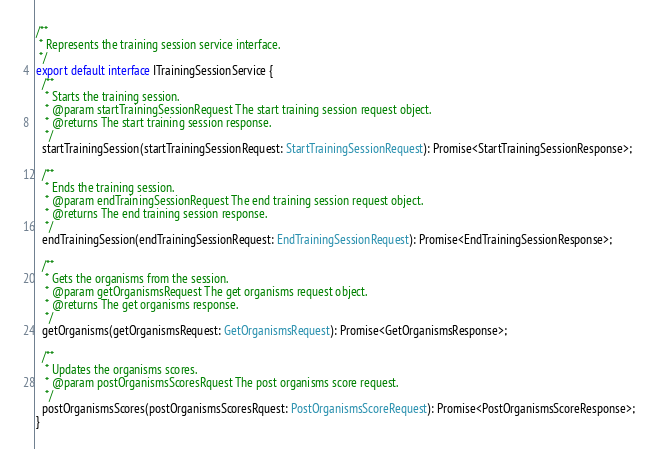<code> <loc_0><loc_0><loc_500><loc_500><_TypeScript_>/**
 * Represents the training session service interface.
 */
export default interface ITrainingSessionService {
  /**
   * Starts the training session.
   * @param startTrainingSessionRequest The start training session request object.
   * @returns The start training session response.
   */
  startTrainingSession(startTrainingSessionRequest: StartTrainingSessionRequest): Promise<StartTrainingSessionResponse>;

  /**
   * Ends the training session.
   * @param endTrainingSessionRequest The end training session request object.
   * @returns The end training session response.
   */
  endTrainingSession(endTrainingSessionRequest: EndTrainingSessionRequest): Promise<EndTrainingSessionResponse>;

  /**
   * Gets the organisms from the session.
   * @param getOrganismsRequest The get organisms request object.
   * @returns The get organisms response.
   */
  getOrganisms(getOrganismsRequest: GetOrganismsRequest): Promise<GetOrganismsResponse>;

  /**
   * Updates the organisms scores.
   * @param postOrganismsScoresRquest The post organisms score request.
   */
  postOrganismsScores(postOrganismsScoresRquest: PostOrganismsScoreRequest): Promise<PostOrganismsScoreResponse>;
}
</code> 